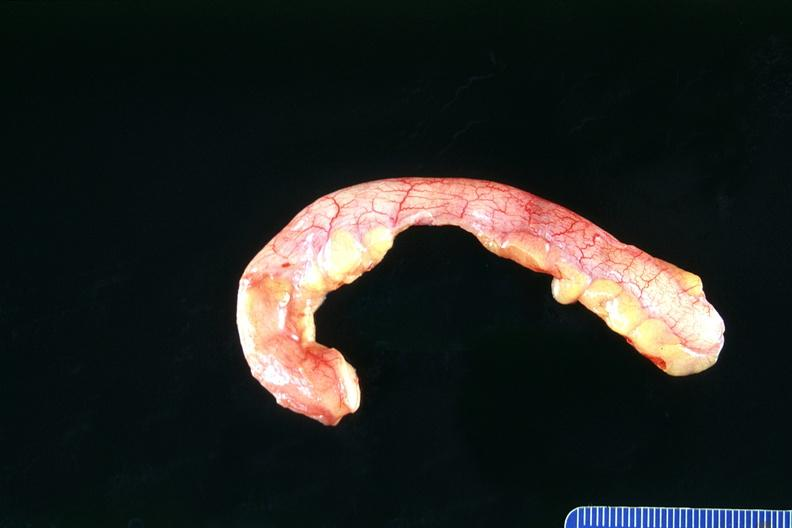does angiogram show normal appendix?
Answer the question using a single word or phrase. No 